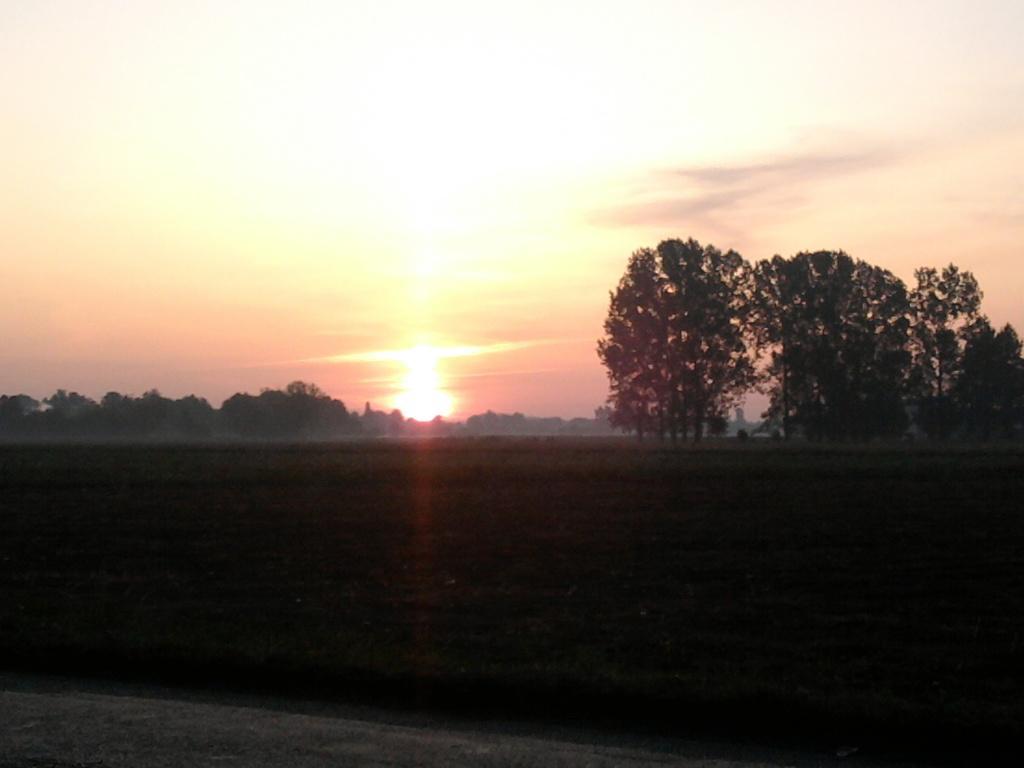Can you describe this image briefly? In this image I can see trees in green color. Background the sky is in white and lite red color. 